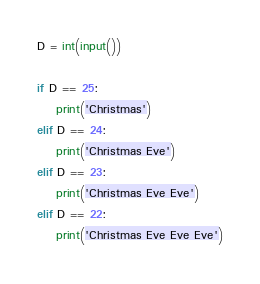Convert code to text. <code><loc_0><loc_0><loc_500><loc_500><_Python_>D = int(input())

if D == 25:
    print('Christmas')
elif D == 24:
    print('Christmas Eve')
elif D == 23:
    print('Christmas Eve Eve')
elif D == 22:
    print('Christmas Eve Eve Eve')
</code> 